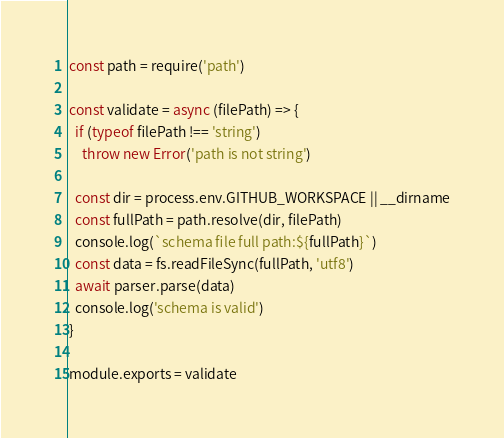<code> <loc_0><loc_0><loc_500><loc_500><_JavaScript_>const path = require('path')

const validate = async (filePath) => {
  if (typeof filePath !== 'string')
    throw new Error('path is not string')

  const dir = process.env.GITHUB_WORKSPACE || __dirname
  const fullPath = path.resolve(dir, filePath)
  console.log(`schema file full path:${fullPath}`)
  const data = fs.readFileSync(fullPath, 'utf8')
  await parser.parse(data)
  console.log('schema is valid')
}

module.exports = validate
</code> 